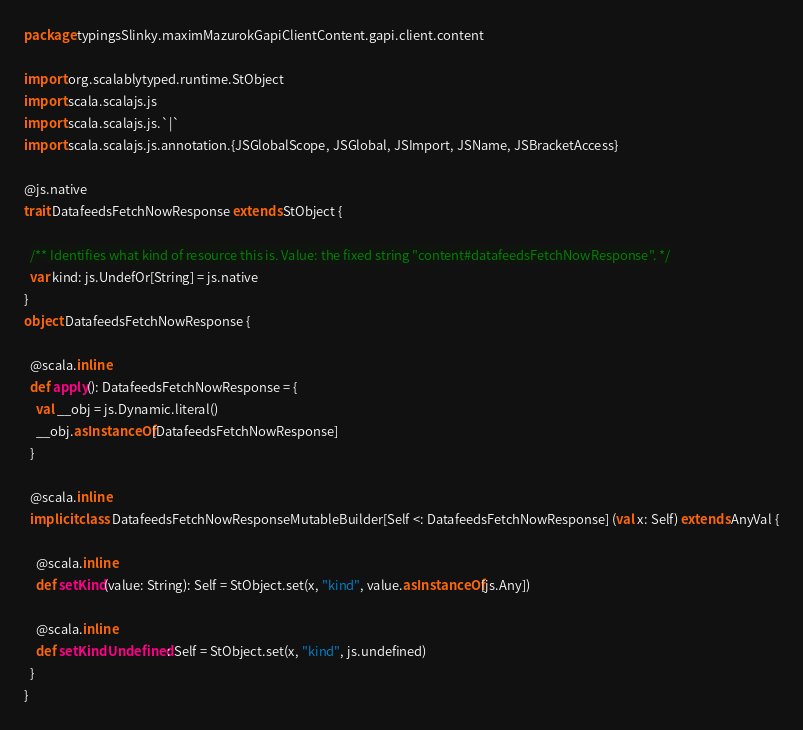<code> <loc_0><loc_0><loc_500><loc_500><_Scala_>package typingsSlinky.maximMazurokGapiClientContent.gapi.client.content

import org.scalablytyped.runtime.StObject
import scala.scalajs.js
import scala.scalajs.js.`|`
import scala.scalajs.js.annotation.{JSGlobalScope, JSGlobal, JSImport, JSName, JSBracketAccess}

@js.native
trait DatafeedsFetchNowResponse extends StObject {
  
  /** Identifies what kind of resource this is. Value: the fixed string "content#datafeedsFetchNowResponse". */
  var kind: js.UndefOr[String] = js.native
}
object DatafeedsFetchNowResponse {
  
  @scala.inline
  def apply(): DatafeedsFetchNowResponse = {
    val __obj = js.Dynamic.literal()
    __obj.asInstanceOf[DatafeedsFetchNowResponse]
  }
  
  @scala.inline
  implicit class DatafeedsFetchNowResponseMutableBuilder[Self <: DatafeedsFetchNowResponse] (val x: Self) extends AnyVal {
    
    @scala.inline
    def setKind(value: String): Self = StObject.set(x, "kind", value.asInstanceOf[js.Any])
    
    @scala.inline
    def setKindUndefined: Self = StObject.set(x, "kind", js.undefined)
  }
}
</code> 